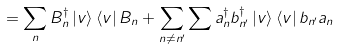Convert formula to latex. <formula><loc_0><loc_0><loc_500><loc_500>= \sum _ { n } B _ { n } ^ { \dagger } \left | v \right \rangle \left \langle v \right | B _ { n } + \sum _ { n \neq n ^ { \prime } } \sum a _ { n } ^ { \dagger } b _ { n ^ { \prime } } ^ { \dagger } \left | v \right \rangle \left \langle v \right | b _ { n ^ { \prime } } a _ { n }</formula> 